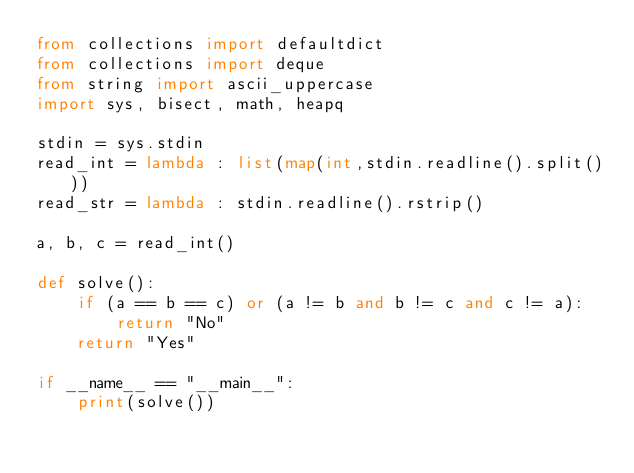<code> <loc_0><loc_0><loc_500><loc_500><_Python_>from collections import defaultdict
from collections import deque
from string import ascii_uppercase
import sys, bisect, math, heapq

stdin = sys.stdin
read_int = lambda : list(map(int,stdin.readline().split()))
read_str = lambda : stdin.readline().rstrip()

a, b, c = read_int()

def solve():
    if (a == b == c) or (a != b and b != c and c != a):
        return "No"
    return "Yes"

if __name__ == "__main__":
    print(solve())</code> 